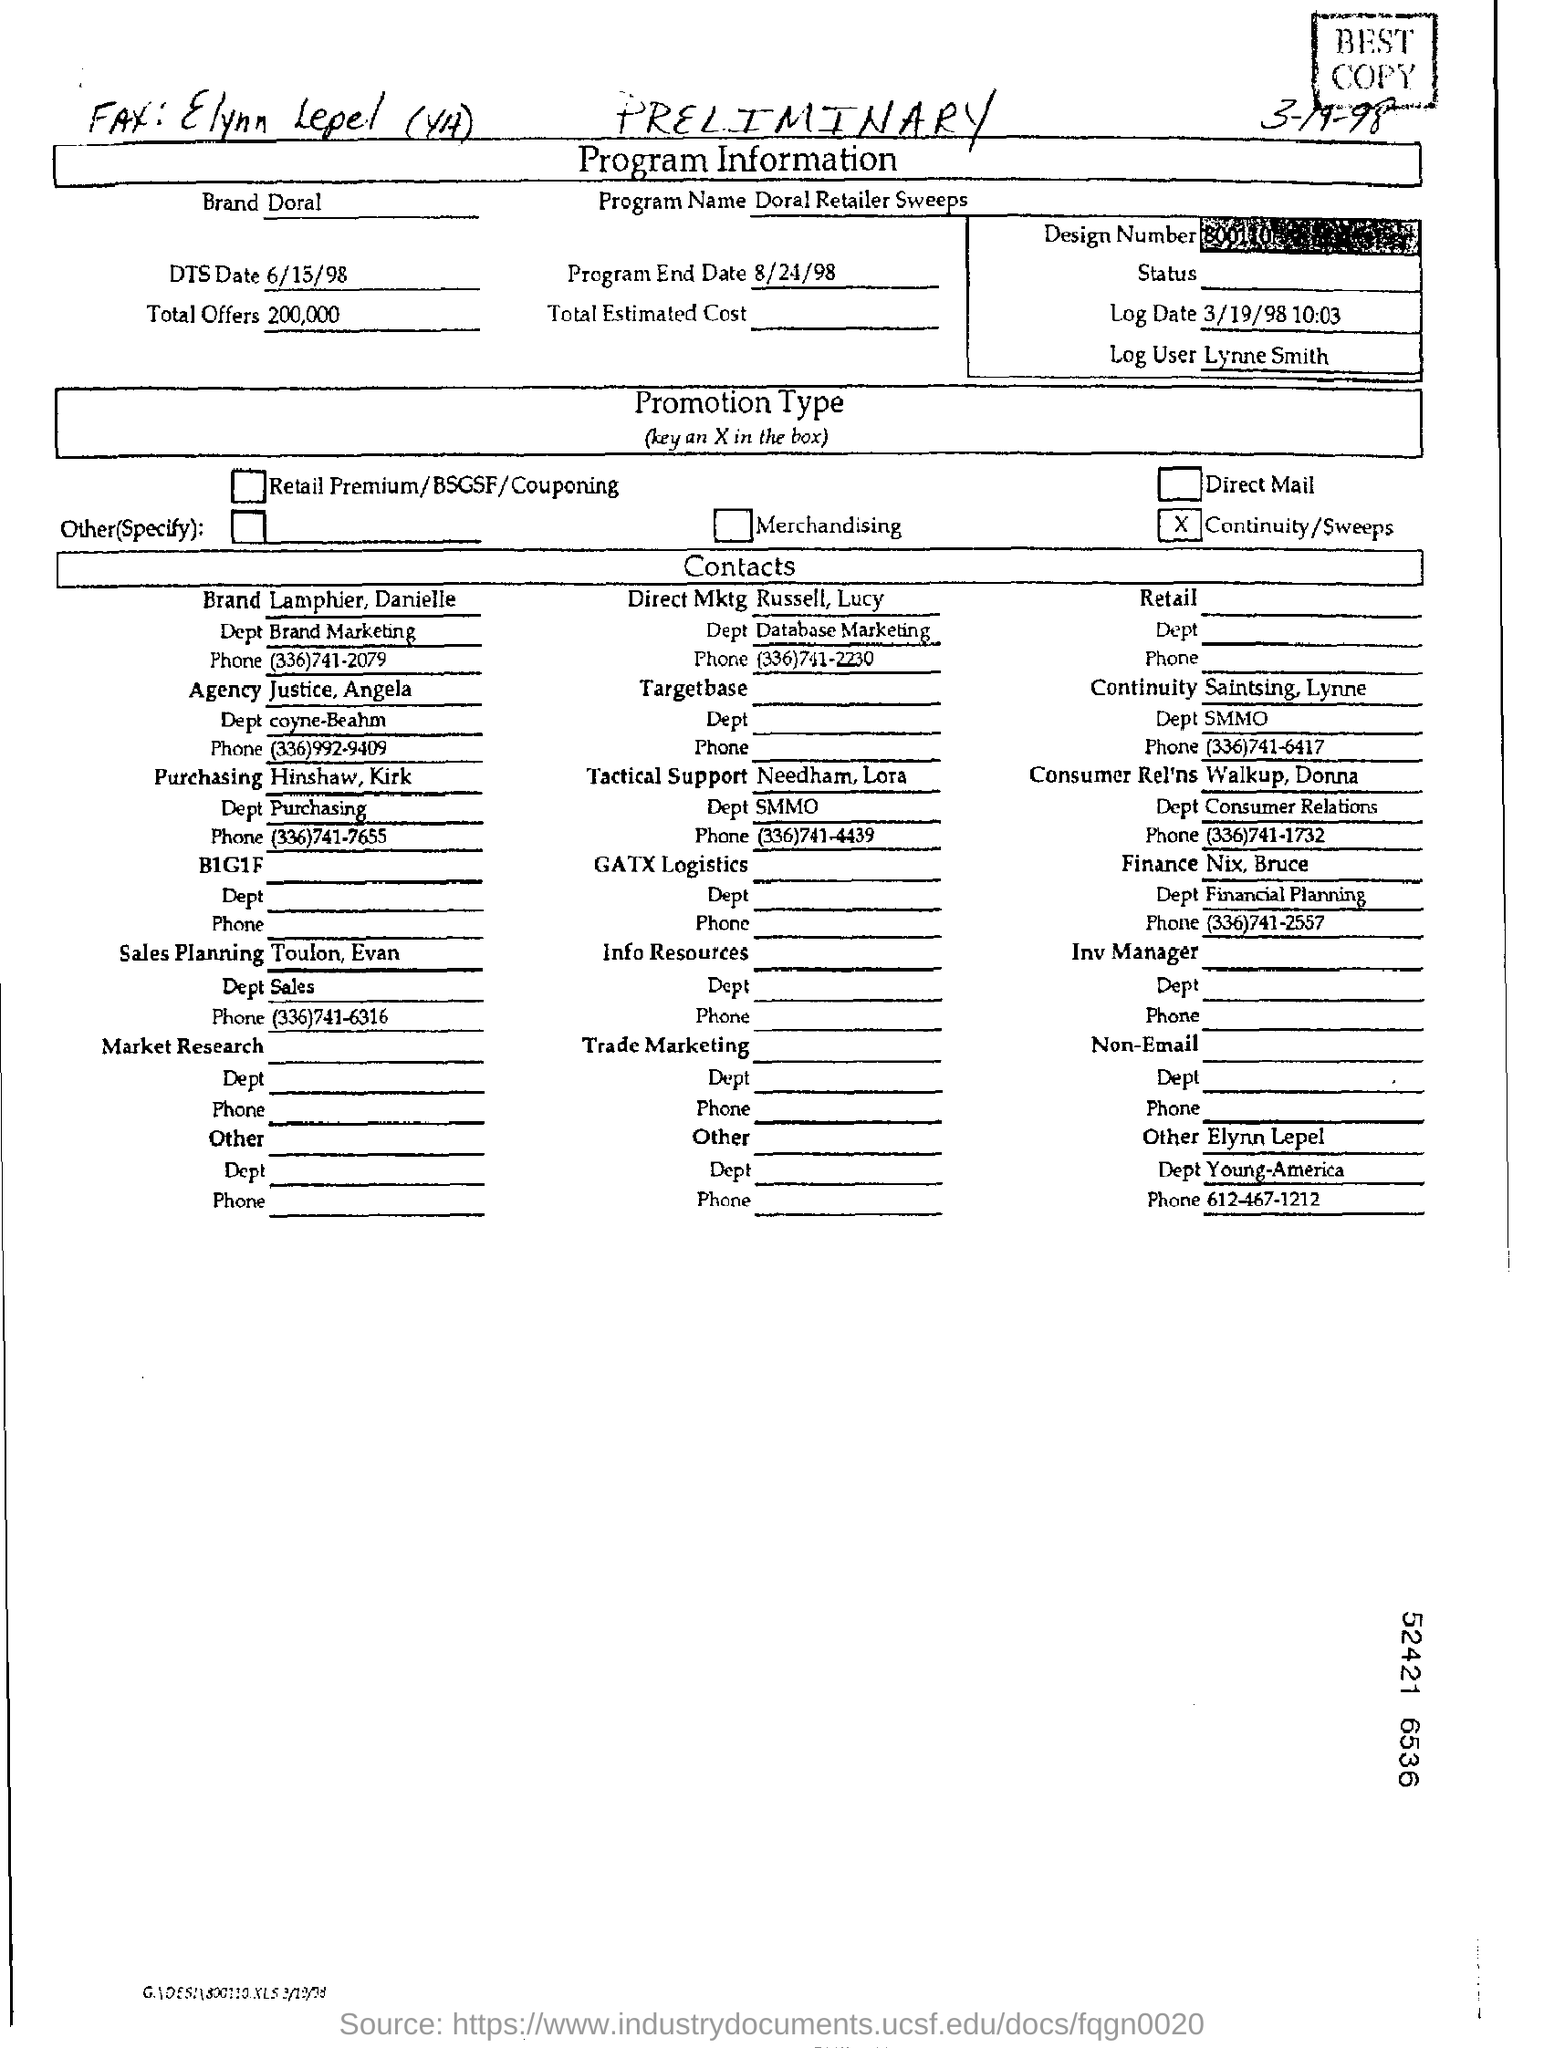Point out several critical features in this image. The program name is "Doral Retailer Sweeps. The log user is Lynne Smith. The total amount of offers is 200,000. 